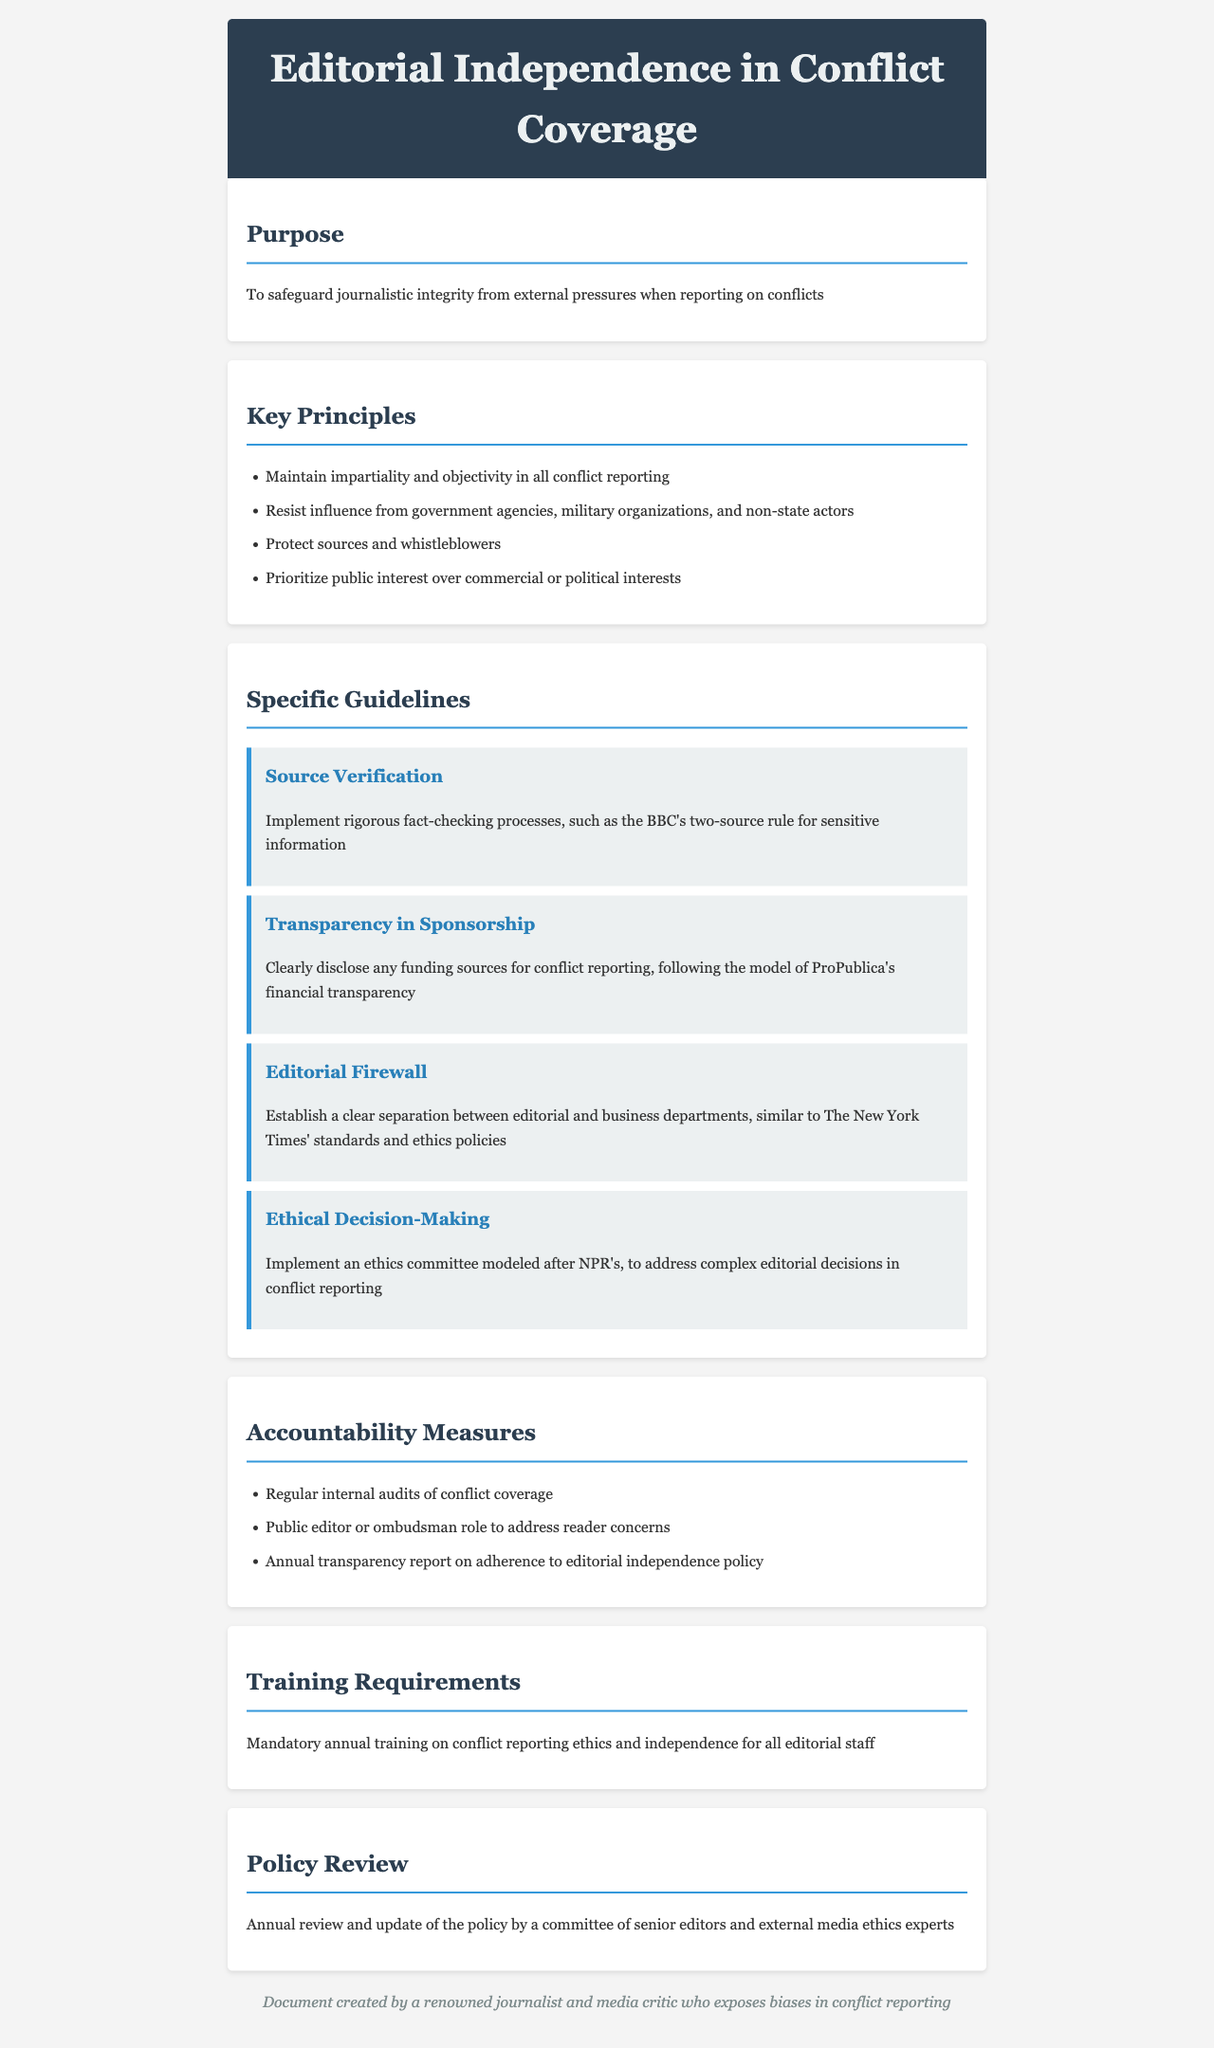What is the main purpose of the policy? The main purpose of the policy is stated as safeguarding journalistic integrity from external pressures when reporting on conflicts.
Answer: safeguarding journalistic integrity from external pressures What are the key principles outlined in the policy? The key principles include maintaining impartiality, resisting influence, protecting sources, and prioritizing public interest.
Answer: impartiality, resisting influence, protecting sources, prioritizing public interest How many specific guidelines are described in the document? The document outlines four specific guidelines related to sourcing, transparency, editorial separation, and ethics.
Answer: four What is the annual training requirement mentioned in the policy? The policy mandates annual training on conflict reporting ethics and independence for all editorial staff.
Answer: mandatory annual training Who is responsible for reviewing the policy annually? The policy review is conducted by a committee composed of senior editors and external media ethics experts.
Answer: a committee of senior editors and external media ethics experts What accountability measure involves a public role? The document mentions a public editor or ombudsman as part of the accountability measures to address reader concerns.
Answer: public editor or ombudsman What guideline emphasizes fact-checking processes? The guideline labeled "Source Verification" highlights the necessity of implementing rigorous fact-checking processes.
Answer: Source Verification Which media outlet's standards are referenced for establishing an editorial firewall? The policy refers to The New York Times' standards and ethics policies for establishing an editorial firewall.
Answer: The New York Times What is the purpose of the ethics committee mentioned in the policy? The ethics committee is intended to address complex editorial decisions in conflict reporting.
Answer: to address complex editorial decisions 